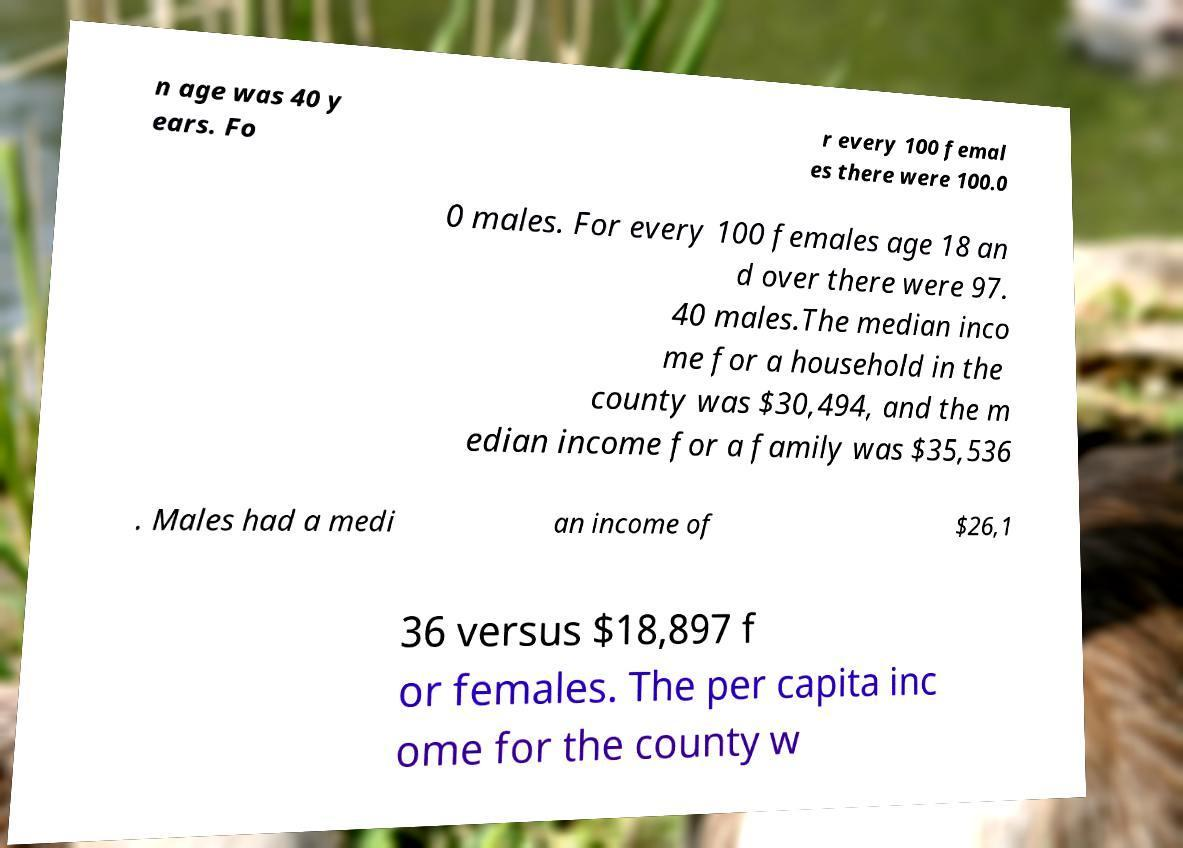What messages or text are displayed in this image? I need them in a readable, typed format. n age was 40 y ears. Fo r every 100 femal es there were 100.0 0 males. For every 100 females age 18 an d over there were 97. 40 males.The median inco me for a household in the county was $30,494, and the m edian income for a family was $35,536 . Males had a medi an income of $26,1 36 versus $18,897 f or females. The per capita inc ome for the county w 